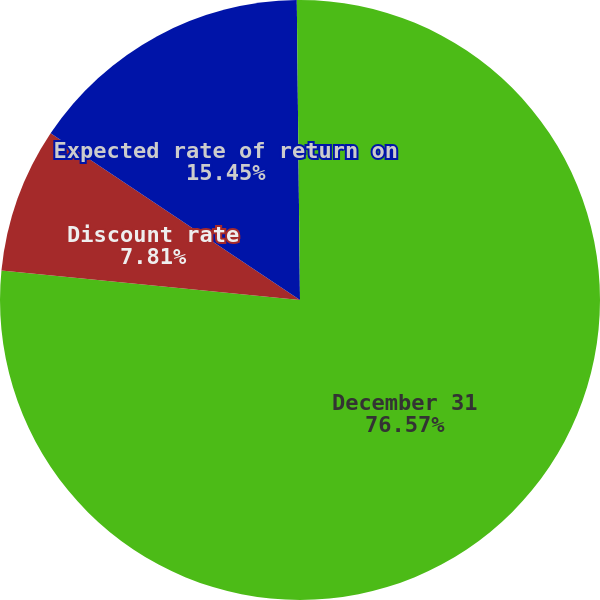Convert chart to OTSL. <chart><loc_0><loc_0><loc_500><loc_500><pie_chart><fcel>December 31<fcel>Discount rate<fcel>Expected rate of return on<fcel>Salary growth rate<nl><fcel>76.57%<fcel>7.81%<fcel>15.45%<fcel>0.17%<nl></chart> 